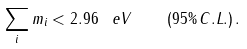<formula> <loc_0><loc_0><loc_500><loc_500>\sum _ { i } m _ { i } < 2 . 9 6 \, \ e V \quad ( 9 5 \% \, C . L . ) \, .</formula> 